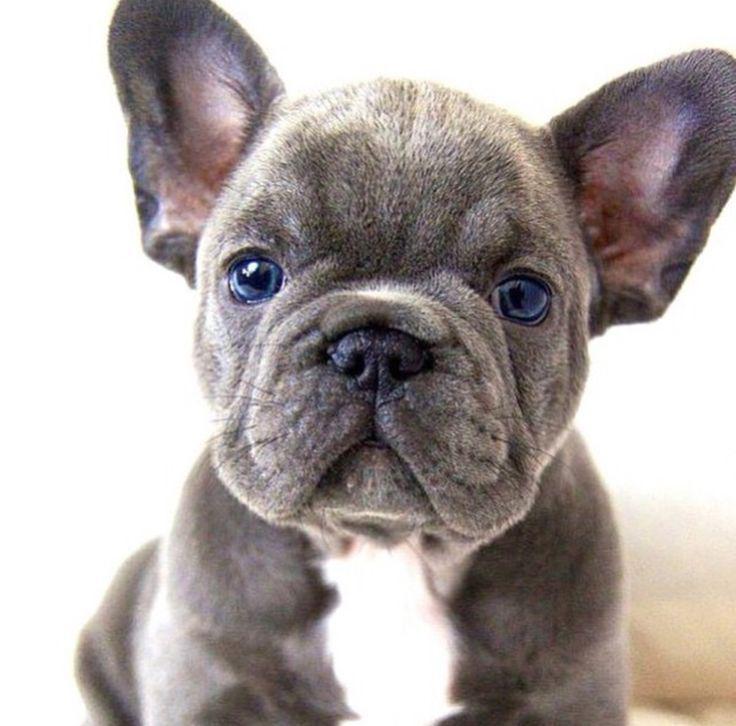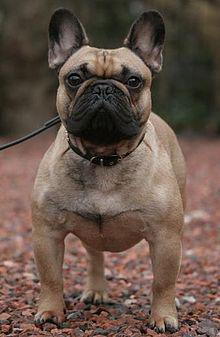The first image is the image on the left, the second image is the image on the right. For the images displayed, is the sentence "There are eight dog legs visible" factually correct? Answer yes or no. No. 